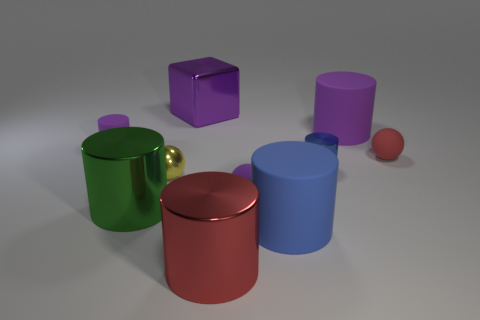Is the number of objects that are in front of the metallic ball greater than the number of small matte balls?
Ensure brevity in your answer.  Yes. What number of small purple rubber cylinders are behind the large green metallic cylinder that is to the left of the tiny red ball?
Give a very brief answer. 1. Does the big red cylinder that is right of the big purple block have the same material as the purple thing that is left of the tiny yellow metallic object?
Ensure brevity in your answer.  No. What material is the ball that is the same color as the large cube?
Provide a succinct answer. Rubber. What number of yellow things have the same shape as the large purple matte object?
Provide a succinct answer. 0. Do the yellow ball and the ball in front of the small yellow sphere have the same material?
Offer a very short reply. No. What is the material of the blue thing that is the same size as the green cylinder?
Provide a short and direct response. Rubber. Are there any green shiny cylinders that have the same size as the green shiny object?
Give a very brief answer. No. There is a red object that is the same size as the purple cube; what is its shape?
Make the answer very short. Cylinder. What number of other things are there of the same color as the small metal cylinder?
Your response must be concise. 1. 